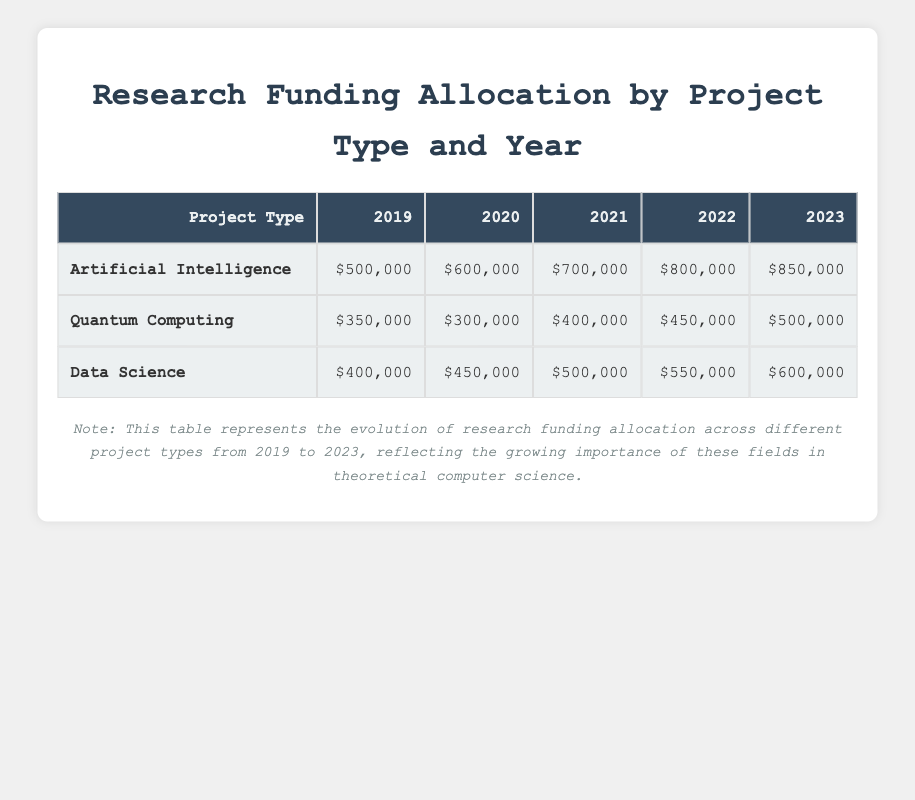What is the amount allocated for Artificial Intelligence projects in 2021? The table shows that the amount allocated for Artificial Intelligence projects in 2021 is $700,000.
Answer: $700,000 What was the total amount allocated for Data Science projects from 2019 to 2023? To find the total amount for Data Science, sum the allocations for each year: 400,000 + 450,000 + 500,000 + 550,000 + 600,000 = 2,500,000.
Answer: $2,500,000 Is the funding for Quantum Computing projects increasing each year? By examining the table, the amounts are: 350,000 for 2019, 300,000 for 2020, 400,000 for 2021, 450,000 for 2022, and 500,000 for 2023. Since the amount in 2020 is lower than in 2019, the funding does not consistently increase every year.
Answer: No What is the difference in funding allocated to Artificial Intelligence between 2022 and 2023? The allocation for Artificial Intelligence in 2022 is $800,000 and for 2023 is $850,000. To find the difference, subtract: 850,000 - 800,000 = 50,000.
Answer: $50,000 Which project type received the highest funding in 2020? Referring to the table, we see the allocations for 2020: Artificial Intelligence is 600,000, Quantum Computing is 300,000, and Data Science is 450,000. The highest amount in 2020 is for Artificial Intelligence.
Answer: Artificial Intelligence What is the average funding amount allocated for Quantum Computing over the years? The allocations for Quantum Computing are: 350,000 (2019), 300,000 (2020), 400,000 (2021), 450,000 (2022), and 500,000 (2023). The total is 350,000 + 300,000 + 400,000 + 450,000 + 500,000 = 2,000,000. There are 5 years, so the average is 2,000,000 / 5 = 400,000.
Answer: $400,000 In which year did Data Science receive the lowest funding? Looking at the table, the amounts for Data Science are: 400,000 in 2019, 450,000 in 2020, 500,000 in 2021, 550,000 in 2022, and 600,000 in 2023. The lowest funding for Data Science occurred in 2019 with 400,000.
Answer: 2019 Is the statement "Artificial Intelligence always received more funding than Data Science" true? The allocations are: AI (500,000 in 2019, 600,000 in 2020, 700,000 in 2021, 800,000 in 2022, and 850,000 in 2023) and Data Science (400,000 in 2019, 450,000 in 2020, 500,000 in 2021, 550,000 in 2022, and 600,000 in 2023). Comparing the two shows that AI received more in every year.
Answer: Yes 